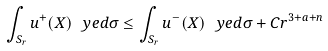<formula> <loc_0><loc_0><loc_500><loc_500>\int _ { S _ { r } } u ^ { + } ( X ) \ y e d \sigma \leq \int _ { S _ { r } } u ^ { - } ( X ) \ y e d \sigma + C r ^ { 3 + a + n }</formula> 